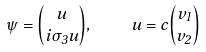<formula> <loc_0><loc_0><loc_500><loc_500>\psi = { u \choose i { \sigma } _ { 3 } u } , \quad u = c { v _ { 1 } \choose v _ { 2 } }</formula> 